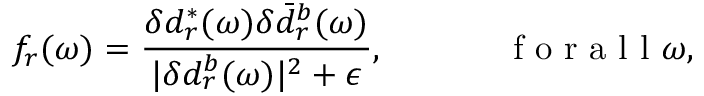Convert formula to latex. <formula><loc_0><loc_0><loc_500><loc_500>f _ { r } ( \omega ) = \frac { \delta d _ { r } ^ { * } ( \omega ) \delta \bar { d } _ { r } ^ { b } ( \omega ) } { | \delta d _ { r } ^ { b } ( \omega ) | ^ { 2 } + \epsilon } , f o r a l l \omega ,</formula> 